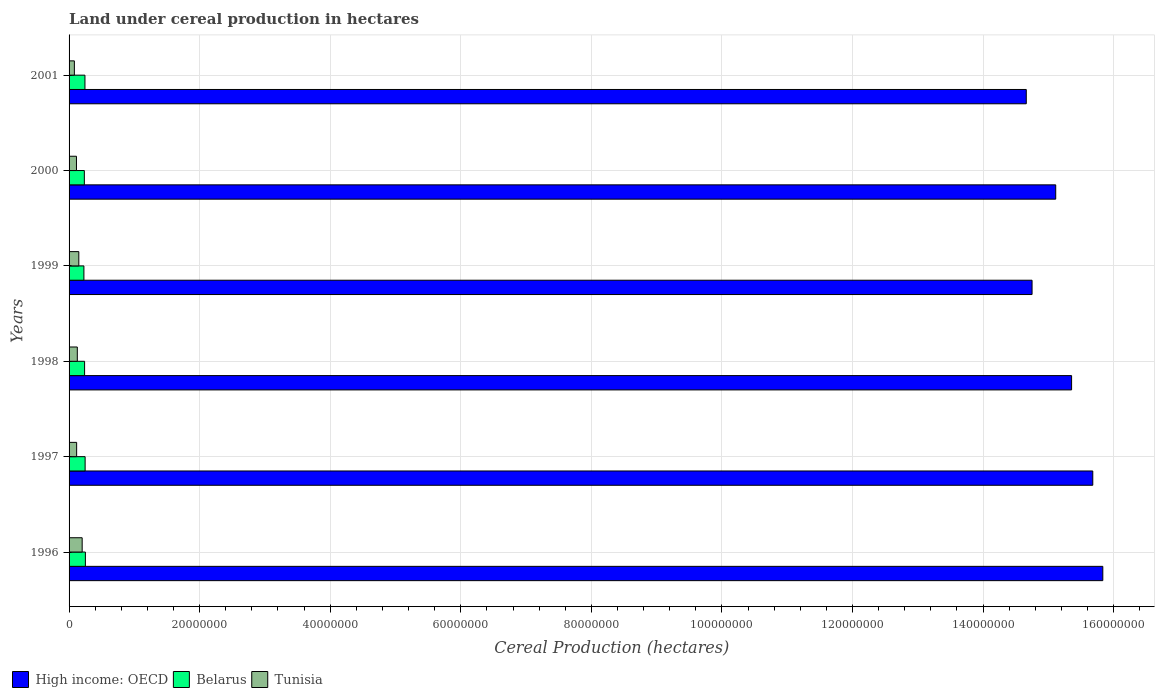How many groups of bars are there?
Make the answer very short. 6. Are the number of bars per tick equal to the number of legend labels?
Give a very brief answer. Yes. Are the number of bars on each tick of the Y-axis equal?
Your answer should be very brief. Yes. How many bars are there on the 2nd tick from the top?
Provide a succinct answer. 3. What is the label of the 1st group of bars from the top?
Ensure brevity in your answer.  2001. What is the land under cereal production in Tunisia in 1996?
Your answer should be compact. 2.01e+06. Across all years, what is the maximum land under cereal production in Belarus?
Ensure brevity in your answer.  2.50e+06. Across all years, what is the minimum land under cereal production in High income: OECD?
Make the answer very short. 1.47e+08. What is the total land under cereal production in High income: OECD in the graph?
Make the answer very short. 9.14e+08. What is the difference between the land under cereal production in Tunisia in 1997 and that in 2001?
Offer a very short reply. 3.46e+05. What is the difference between the land under cereal production in High income: OECD in 2000 and the land under cereal production in Belarus in 1998?
Offer a terse response. 1.49e+08. What is the average land under cereal production in High income: OECD per year?
Provide a short and direct response. 1.52e+08. In the year 1998, what is the difference between the land under cereal production in High income: OECD and land under cereal production in Belarus?
Your answer should be compact. 1.51e+08. In how many years, is the land under cereal production in Belarus greater than 88000000 hectares?
Give a very brief answer. 0. What is the ratio of the land under cereal production in Belarus in 2000 to that in 2001?
Provide a short and direct response. 0.96. What is the difference between the highest and the second highest land under cereal production in Tunisia?
Offer a very short reply. 5.13e+05. What is the difference between the highest and the lowest land under cereal production in Belarus?
Your response must be concise. 2.26e+05. In how many years, is the land under cereal production in Belarus greater than the average land under cereal production in Belarus taken over all years?
Make the answer very short. 3. Is the sum of the land under cereal production in Belarus in 1997 and 1998 greater than the maximum land under cereal production in High income: OECD across all years?
Your answer should be compact. No. What does the 3rd bar from the top in 2001 represents?
Your answer should be very brief. High income: OECD. What does the 1st bar from the bottom in 2001 represents?
Offer a terse response. High income: OECD. Is it the case that in every year, the sum of the land under cereal production in Tunisia and land under cereal production in High income: OECD is greater than the land under cereal production in Belarus?
Your answer should be compact. Yes. How many bars are there?
Provide a succinct answer. 18. Are the values on the major ticks of X-axis written in scientific E-notation?
Your answer should be compact. No. Does the graph contain grids?
Offer a terse response. Yes. How many legend labels are there?
Your answer should be very brief. 3. What is the title of the graph?
Provide a short and direct response. Land under cereal production in hectares. Does "Estonia" appear as one of the legend labels in the graph?
Your answer should be very brief. No. What is the label or title of the X-axis?
Give a very brief answer. Cereal Production (hectares). What is the label or title of the Y-axis?
Provide a succinct answer. Years. What is the Cereal Production (hectares) of High income: OECD in 1996?
Your answer should be very brief. 1.58e+08. What is the Cereal Production (hectares) of Belarus in 1996?
Provide a short and direct response. 2.50e+06. What is the Cereal Production (hectares) in Tunisia in 1996?
Give a very brief answer. 2.01e+06. What is the Cereal Production (hectares) in High income: OECD in 1997?
Your response must be concise. 1.57e+08. What is the Cereal Production (hectares) of Belarus in 1997?
Make the answer very short. 2.46e+06. What is the Cereal Production (hectares) in Tunisia in 1997?
Provide a short and direct response. 1.16e+06. What is the Cereal Production (hectares) in High income: OECD in 1998?
Your answer should be compact. 1.54e+08. What is the Cereal Production (hectares) in Belarus in 1998?
Your response must be concise. 2.38e+06. What is the Cereal Production (hectares) in Tunisia in 1998?
Your answer should be very brief. 1.26e+06. What is the Cereal Production (hectares) in High income: OECD in 1999?
Offer a terse response. 1.48e+08. What is the Cereal Production (hectares) in Belarus in 1999?
Offer a very short reply. 2.27e+06. What is the Cereal Production (hectares) in Tunisia in 1999?
Give a very brief answer. 1.49e+06. What is the Cereal Production (hectares) of High income: OECD in 2000?
Offer a very short reply. 1.51e+08. What is the Cereal Production (hectares) in Belarus in 2000?
Keep it short and to the point. 2.34e+06. What is the Cereal Production (hectares) in Tunisia in 2000?
Offer a terse response. 1.13e+06. What is the Cereal Production (hectares) of High income: OECD in 2001?
Make the answer very short. 1.47e+08. What is the Cereal Production (hectares) of Belarus in 2001?
Your answer should be very brief. 2.43e+06. What is the Cereal Production (hectares) of Tunisia in 2001?
Your answer should be compact. 8.13e+05. Across all years, what is the maximum Cereal Production (hectares) of High income: OECD?
Keep it short and to the point. 1.58e+08. Across all years, what is the maximum Cereal Production (hectares) of Belarus?
Ensure brevity in your answer.  2.50e+06. Across all years, what is the maximum Cereal Production (hectares) in Tunisia?
Provide a short and direct response. 2.01e+06. Across all years, what is the minimum Cereal Production (hectares) of High income: OECD?
Make the answer very short. 1.47e+08. Across all years, what is the minimum Cereal Production (hectares) in Belarus?
Keep it short and to the point. 2.27e+06. Across all years, what is the minimum Cereal Production (hectares) in Tunisia?
Provide a succinct answer. 8.13e+05. What is the total Cereal Production (hectares) of High income: OECD in the graph?
Your answer should be very brief. 9.14e+08. What is the total Cereal Production (hectares) in Belarus in the graph?
Your response must be concise. 1.44e+07. What is the total Cereal Production (hectares) of Tunisia in the graph?
Your response must be concise. 7.87e+06. What is the difference between the Cereal Production (hectares) in High income: OECD in 1996 and that in 1997?
Provide a short and direct response. 1.54e+06. What is the difference between the Cereal Production (hectares) in Belarus in 1996 and that in 1997?
Make the answer very short. 4.05e+04. What is the difference between the Cereal Production (hectares) of Tunisia in 1996 and that in 1997?
Your response must be concise. 8.46e+05. What is the difference between the Cereal Production (hectares) in High income: OECD in 1996 and that in 1998?
Keep it short and to the point. 4.78e+06. What is the difference between the Cereal Production (hectares) in Belarus in 1996 and that in 1998?
Make the answer very short. 1.22e+05. What is the difference between the Cereal Production (hectares) of Tunisia in 1996 and that in 1998?
Ensure brevity in your answer.  7.44e+05. What is the difference between the Cereal Production (hectares) in High income: OECD in 1996 and that in 1999?
Offer a terse response. 1.08e+07. What is the difference between the Cereal Production (hectares) of Belarus in 1996 and that in 1999?
Keep it short and to the point. 2.26e+05. What is the difference between the Cereal Production (hectares) in Tunisia in 1996 and that in 1999?
Keep it short and to the point. 5.13e+05. What is the difference between the Cereal Production (hectares) of High income: OECD in 1996 and that in 2000?
Ensure brevity in your answer.  7.21e+06. What is the difference between the Cereal Production (hectares) in Belarus in 1996 and that in 2000?
Give a very brief answer. 1.60e+05. What is the difference between the Cereal Production (hectares) in Tunisia in 1996 and that in 2000?
Ensure brevity in your answer.  8.72e+05. What is the difference between the Cereal Production (hectares) in High income: OECD in 1996 and that in 2001?
Your answer should be compact. 1.17e+07. What is the difference between the Cereal Production (hectares) of Belarus in 1996 and that in 2001?
Make the answer very short. 6.68e+04. What is the difference between the Cereal Production (hectares) in Tunisia in 1996 and that in 2001?
Make the answer very short. 1.19e+06. What is the difference between the Cereal Production (hectares) in High income: OECD in 1997 and that in 1998?
Ensure brevity in your answer.  3.25e+06. What is the difference between the Cereal Production (hectares) of Belarus in 1997 and that in 1998?
Make the answer very short. 8.12e+04. What is the difference between the Cereal Production (hectares) in Tunisia in 1997 and that in 1998?
Your answer should be very brief. -1.03e+05. What is the difference between the Cereal Production (hectares) in High income: OECD in 1997 and that in 1999?
Provide a short and direct response. 9.30e+06. What is the difference between the Cereal Production (hectares) in Belarus in 1997 and that in 1999?
Your response must be concise. 1.86e+05. What is the difference between the Cereal Production (hectares) in Tunisia in 1997 and that in 1999?
Make the answer very short. -3.33e+05. What is the difference between the Cereal Production (hectares) in High income: OECD in 1997 and that in 2000?
Provide a short and direct response. 5.68e+06. What is the difference between the Cereal Production (hectares) of Belarus in 1997 and that in 2000?
Offer a terse response. 1.20e+05. What is the difference between the Cereal Production (hectares) in Tunisia in 1997 and that in 2000?
Provide a succinct answer. 2.54e+04. What is the difference between the Cereal Production (hectares) of High income: OECD in 1997 and that in 2001?
Your answer should be compact. 1.02e+07. What is the difference between the Cereal Production (hectares) of Belarus in 1997 and that in 2001?
Your response must be concise. 2.63e+04. What is the difference between the Cereal Production (hectares) of Tunisia in 1997 and that in 2001?
Ensure brevity in your answer.  3.46e+05. What is the difference between the Cereal Production (hectares) of High income: OECD in 1998 and that in 1999?
Make the answer very short. 6.05e+06. What is the difference between the Cereal Production (hectares) of Belarus in 1998 and that in 1999?
Offer a terse response. 1.04e+05. What is the difference between the Cereal Production (hectares) of Tunisia in 1998 and that in 1999?
Your response must be concise. -2.30e+05. What is the difference between the Cereal Production (hectares) of High income: OECD in 1998 and that in 2000?
Your answer should be compact. 2.43e+06. What is the difference between the Cereal Production (hectares) of Belarus in 1998 and that in 2000?
Provide a short and direct response. 3.83e+04. What is the difference between the Cereal Production (hectares) of Tunisia in 1998 and that in 2000?
Make the answer very short. 1.28e+05. What is the difference between the Cereal Production (hectares) in High income: OECD in 1998 and that in 2001?
Offer a very short reply. 6.94e+06. What is the difference between the Cereal Production (hectares) in Belarus in 1998 and that in 2001?
Your answer should be very brief. -5.49e+04. What is the difference between the Cereal Production (hectares) of Tunisia in 1998 and that in 2001?
Your answer should be compact. 4.49e+05. What is the difference between the Cereal Production (hectares) of High income: OECD in 1999 and that in 2000?
Offer a terse response. -3.62e+06. What is the difference between the Cereal Production (hectares) in Belarus in 1999 and that in 2000?
Provide a succinct answer. -6.60e+04. What is the difference between the Cereal Production (hectares) of Tunisia in 1999 and that in 2000?
Your answer should be very brief. 3.58e+05. What is the difference between the Cereal Production (hectares) in High income: OECD in 1999 and that in 2001?
Make the answer very short. 8.86e+05. What is the difference between the Cereal Production (hectares) of Belarus in 1999 and that in 2001?
Provide a short and direct response. -1.59e+05. What is the difference between the Cereal Production (hectares) in Tunisia in 1999 and that in 2001?
Keep it short and to the point. 6.79e+05. What is the difference between the Cereal Production (hectares) in High income: OECD in 2000 and that in 2001?
Ensure brevity in your answer.  4.51e+06. What is the difference between the Cereal Production (hectares) in Belarus in 2000 and that in 2001?
Offer a very short reply. -9.32e+04. What is the difference between the Cereal Production (hectares) of Tunisia in 2000 and that in 2001?
Your answer should be compact. 3.21e+05. What is the difference between the Cereal Production (hectares) in High income: OECD in 1996 and the Cereal Production (hectares) in Belarus in 1997?
Your answer should be compact. 1.56e+08. What is the difference between the Cereal Production (hectares) in High income: OECD in 1996 and the Cereal Production (hectares) in Tunisia in 1997?
Provide a succinct answer. 1.57e+08. What is the difference between the Cereal Production (hectares) of Belarus in 1996 and the Cereal Production (hectares) of Tunisia in 1997?
Your answer should be very brief. 1.34e+06. What is the difference between the Cereal Production (hectares) in High income: OECD in 1996 and the Cereal Production (hectares) in Belarus in 1998?
Your answer should be very brief. 1.56e+08. What is the difference between the Cereal Production (hectares) in High income: OECD in 1996 and the Cereal Production (hectares) in Tunisia in 1998?
Your answer should be compact. 1.57e+08. What is the difference between the Cereal Production (hectares) in Belarus in 1996 and the Cereal Production (hectares) in Tunisia in 1998?
Your response must be concise. 1.24e+06. What is the difference between the Cereal Production (hectares) of High income: OECD in 1996 and the Cereal Production (hectares) of Belarus in 1999?
Your answer should be compact. 1.56e+08. What is the difference between the Cereal Production (hectares) in High income: OECD in 1996 and the Cereal Production (hectares) in Tunisia in 1999?
Offer a terse response. 1.57e+08. What is the difference between the Cereal Production (hectares) of Belarus in 1996 and the Cereal Production (hectares) of Tunisia in 1999?
Ensure brevity in your answer.  1.01e+06. What is the difference between the Cereal Production (hectares) in High income: OECD in 1996 and the Cereal Production (hectares) in Belarus in 2000?
Your response must be concise. 1.56e+08. What is the difference between the Cereal Production (hectares) of High income: OECD in 1996 and the Cereal Production (hectares) of Tunisia in 2000?
Provide a short and direct response. 1.57e+08. What is the difference between the Cereal Production (hectares) in Belarus in 1996 and the Cereal Production (hectares) in Tunisia in 2000?
Make the answer very short. 1.36e+06. What is the difference between the Cereal Production (hectares) of High income: OECD in 1996 and the Cereal Production (hectares) of Belarus in 2001?
Offer a terse response. 1.56e+08. What is the difference between the Cereal Production (hectares) in High income: OECD in 1996 and the Cereal Production (hectares) in Tunisia in 2001?
Keep it short and to the point. 1.58e+08. What is the difference between the Cereal Production (hectares) of Belarus in 1996 and the Cereal Production (hectares) of Tunisia in 2001?
Offer a terse response. 1.69e+06. What is the difference between the Cereal Production (hectares) in High income: OECD in 1997 and the Cereal Production (hectares) in Belarus in 1998?
Your response must be concise. 1.54e+08. What is the difference between the Cereal Production (hectares) of High income: OECD in 1997 and the Cereal Production (hectares) of Tunisia in 1998?
Ensure brevity in your answer.  1.56e+08. What is the difference between the Cereal Production (hectares) in Belarus in 1997 and the Cereal Production (hectares) in Tunisia in 1998?
Provide a short and direct response. 1.20e+06. What is the difference between the Cereal Production (hectares) of High income: OECD in 1997 and the Cereal Production (hectares) of Belarus in 1999?
Ensure brevity in your answer.  1.55e+08. What is the difference between the Cereal Production (hectares) of High income: OECD in 1997 and the Cereal Production (hectares) of Tunisia in 1999?
Your answer should be compact. 1.55e+08. What is the difference between the Cereal Production (hectares) of Belarus in 1997 and the Cereal Production (hectares) of Tunisia in 1999?
Provide a succinct answer. 9.66e+05. What is the difference between the Cereal Production (hectares) of High income: OECD in 1997 and the Cereal Production (hectares) of Belarus in 2000?
Make the answer very short. 1.54e+08. What is the difference between the Cereal Production (hectares) in High income: OECD in 1997 and the Cereal Production (hectares) in Tunisia in 2000?
Provide a short and direct response. 1.56e+08. What is the difference between the Cereal Production (hectares) in Belarus in 1997 and the Cereal Production (hectares) in Tunisia in 2000?
Offer a terse response. 1.32e+06. What is the difference between the Cereal Production (hectares) of High income: OECD in 1997 and the Cereal Production (hectares) of Belarus in 2001?
Ensure brevity in your answer.  1.54e+08. What is the difference between the Cereal Production (hectares) in High income: OECD in 1997 and the Cereal Production (hectares) in Tunisia in 2001?
Keep it short and to the point. 1.56e+08. What is the difference between the Cereal Production (hectares) of Belarus in 1997 and the Cereal Production (hectares) of Tunisia in 2001?
Give a very brief answer. 1.65e+06. What is the difference between the Cereal Production (hectares) in High income: OECD in 1998 and the Cereal Production (hectares) in Belarus in 1999?
Your answer should be very brief. 1.51e+08. What is the difference between the Cereal Production (hectares) in High income: OECD in 1998 and the Cereal Production (hectares) in Tunisia in 1999?
Your answer should be compact. 1.52e+08. What is the difference between the Cereal Production (hectares) of Belarus in 1998 and the Cereal Production (hectares) of Tunisia in 1999?
Your answer should be very brief. 8.85e+05. What is the difference between the Cereal Production (hectares) of High income: OECD in 1998 and the Cereal Production (hectares) of Belarus in 2000?
Offer a very short reply. 1.51e+08. What is the difference between the Cereal Production (hectares) in High income: OECD in 1998 and the Cereal Production (hectares) in Tunisia in 2000?
Offer a very short reply. 1.52e+08. What is the difference between the Cereal Production (hectares) in Belarus in 1998 and the Cereal Production (hectares) in Tunisia in 2000?
Ensure brevity in your answer.  1.24e+06. What is the difference between the Cereal Production (hectares) of High income: OECD in 1998 and the Cereal Production (hectares) of Belarus in 2001?
Provide a succinct answer. 1.51e+08. What is the difference between the Cereal Production (hectares) of High income: OECD in 1998 and the Cereal Production (hectares) of Tunisia in 2001?
Provide a short and direct response. 1.53e+08. What is the difference between the Cereal Production (hectares) in Belarus in 1998 and the Cereal Production (hectares) in Tunisia in 2001?
Your answer should be very brief. 1.56e+06. What is the difference between the Cereal Production (hectares) in High income: OECD in 1999 and the Cereal Production (hectares) in Belarus in 2000?
Your response must be concise. 1.45e+08. What is the difference between the Cereal Production (hectares) of High income: OECD in 1999 and the Cereal Production (hectares) of Tunisia in 2000?
Give a very brief answer. 1.46e+08. What is the difference between the Cereal Production (hectares) of Belarus in 1999 and the Cereal Production (hectares) of Tunisia in 2000?
Your answer should be very brief. 1.14e+06. What is the difference between the Cereal Production (hectares) in High income: OECD in 1999 and the Cereal Production (hectares) in Belarus in 2001?
Provide a succinct answer. 1.45e+08. What is the difference between the Cereal Production (hectares) in High income: OECD in 1999 and the Cereal Production (hectares) in Tunisia in 2001?
Your answer should be very brief. 1.47e+08. What is the difference between the Cereal Production (hectares) in Belarus in 1999 and the Cereal Production (hectares) in Tunisia in 2001?
Provide a succinct answer. 1.46e+06. What is the difference between the Cereal Production (hectares) of High income: OECD in 2000 and the Cereal Production (hectares) of Belarus in 2001?
Your answer should be compact. 1.49e+08. What is the difference between the Cereal Production (hectares) of High income: OECD in 2000 and the Cereal Production (hectares) of Tunisia in 2001?
Your answer should be very brief. 1.50e+08. What is the difference between the Cereal Production (hectares) of Belarus in 2000 and the Cereal Production (hectares) of Tunisia in 2001?
Provide a succinct answer. 1.53e+06. What is the average Cereal Production (hectares) of High income: OECD per year?
Your answer should be very brief. 1.52e+08. What is the average Cereal Production (hectares) of Belarus per year?
Make the answer very short. 2.40e+06. What is the average Cereal Production (hectares) in Tunisia per year?
Provide a succinct answer. 1.31e+06. In the year 1996, what is the difference between the Cereal Production (hectares) of High income: OECD and Cereal Production (hectares) of Belarus?
Make the answer very short. 1.56e+08. In the year 1996, what is the difference between the Cereal Production (hectares) of High income: OECD and Cereal Production (hectares) of Tunisia?
Make the answer very short. 1.56e+08. In the year 1996, what is the difference between the Cereal Production (hectares) of Belarus and Cereal Production (hectares) of Tunisia?
Give a very brief answer. 4.93e+05. In the year 1997, what is the difference between the Cereal Production (hectares) of High income: OECD and Cereal Production (hectares) of Belarus?
Make the answer very short. 1.54e+08. In the year 1997, what is the difference between the Cereal Production (hectares) in High income: OECD and Cereal Production (hectares) in Tunisia?
Provide a succinct answer. 1.56e+08. In the year 1997, what is the difference between the Cereal Production (hectares) in Belarus and Cereal Production (hectares) in Tunisia?
Offer a terse response. 1.30e+06. In the year 1998, what is the difference between the Cereal Production (hectares) of High income: OECD and Cereal Production (hectares) of Belarus?
Your answer should be compact. 1.51e+08. In the year 1998, what is the difference between the Cereal Production (hectares) in High income: OECD and Cereal Production (hectares) in Tunisia?
Offer a very short reply. 1.52e+08. In the year 1998, what is the difference between the Cereal Production (hectares) of Belarus and Cereal Production (hectares) of Tunisia?
Keep it short and to the point. 1.12e+06. In the year 1999, what is the difference between the Cereal Production (hectares) in High income: OECD and Cereal Production (hectares) in Belarus?
Your answer should be compact. 1.45e+08. In the year 1999, what is the difference between the Cereal Production (hectares) of High income: OECD and Cereal Production (hectares) of Tunisia?
Your answer should be compact. 1.46e+08. In the year 1999, what is the difference between the Cereal Production (hectares) of Belarus and Cereal Production (hectares) of Tunisia?
Your answer should be very brief. 7.81e+05. In the year 2000, what is the difference between the Cereal Production (hectares) of High income: OECD and Cereal Production (hectares) of Belarus?
Give a very brief answer. 1.49e+08. In the year 2000, what is the difference between the Cereal Production (hectares) in High income: OECD and Cereal Production (hectares) in Tunisia?
Your response must be concise. 1.50e+08. In the year 2000, what is the difference between the Cereal Production (hectares) in Belarus and Cereal Production (hectares) in Tunisia?
Keep it short and to the point. 1.20e+06. In the year 2001, what is the difference between the Cereal Production (hectares) of High income: OECD and Cereal Production (hectares) of Belarus?
Offer a very short reply. 1.44e+08. In the year 2001, what is the difference between the Cereal Production (hectares) in High income: OECD and Cereal Production (hectares) in Tunisia?
Provide a short and direct response. 1.46e+08. In the year 2001, what is the difference between the Cereal Production (hectares) of Belarus and Cereal Production (hectares) of Tunisia?
Offer a terse response. 1.62e+06. What is the ratio of the Cereal Production (hectares) in High income: OECD in 1996 to that in 1997?
Make the answer very short. 1.01. What is the ratio of the Cereal Production (hectares) in Belarus in 1996 to that in 1997?
Your response must be concise. 1.02. What is the ratio of the Cereal Production (hectares) in Tunisia in 1996 to that in 1997?
Ensure brevity in your answer.  1.73. What is the ratio of the Cereal Production (hectares) in High income: OECD in 1996 to that in 1998?
Provide a succinct answer. 1.03. What is the ratio of the Cereal Production (hectares) in Belarus in 1996 to that in 1998?
Your answer should be very brief. 1.05. What is the ratio of the Cereal Production (hectares) in Tunisia in 1996 to that in 1998?
Your answer should be compact. 1.59. What is the ratio of the Cereal Production (hectares) of High income: OECD in 1996 to that in 1999?
Offer a very short reply. 1.07. What is the ratio of the Cereal Production (hectares) of Belarus in 1996 to that in 1999?
Provide a short and direct response. 1.1. What is the ratio of the Cereal Production (hectares) in Tunisia in 1996 to that in 1999?
Keep it short and to the point. 1.34. What is the ratio of the Cereal Production (hectares) of High income: OECD in 1996 to that in 2000?
Your answer should be compact. 1.05. What is the ratio of the Cereal Production (hectares) in Belarus in 1996 to that in 2000?
Provide a short and direct response. 1.07. What is the ratio of the Cereal Production (hectares) in Tunisia in 1996 to that in 2000?
Provide a short and direct response. 1.77. What is the ratio of the Cereal Production (hectares) of High income: OECD in 1996 to that in 2001?
Provide a short and direct response. 1.08. What is the ratio of the Cereal Production (hectares) in Belarus in 1996 to that in 2001?
Make the answer very short. 1.03. What is the ratio of the Cereal Production (hectares) in Tunisia in 1996 to that in 2001?
Provide a short and direct response. 2.47. What is the ratio of the Cereal Production (hectares) in High income: OECD in 1997 to that in 1998?
Provide a succinct answer. 1.02. What is the ratio of the Cereal Production (hectares) of Belarus in 1997 to that in 1998?
Give a very brief answer. 1.03. What is the ratio of the Cereal Production (hectares) in Tunisia in 1997 to that in 1998?
Offer a very short reply. 0.92. What is the ratio of the Cereal Production (hectares) in High income: OECD in 1997 to that in 1999?
Ensure brevity in your answer.  1.06. What is the ratio of the Cereal Production (hectares) in Belarus in 1997 to that in 1999?
Your answer should be very brief. 1.08. What is the ratio of the Cereal Production (hectares) in Tunisia in 1997 to that in 1999?
Offer a very short reply. 0.78. What is the ratio of the Cereal Production (hectares) of High income: OECD in 1997 to that in 2000?
Your response must be concise. 1.04. What is the ratio of the Cereal Production (hectares) in Belarus in 1997 to that in 2000?
Your answer should be very brief. 1.05. What is the ratio of the Cereal Production (hectares) in Tunisia in 1997 to that in 2000?
Ensure brevity in your answer.  1.02. What is the ratio of the Cereal Production (hectares) of High income: OECD in 1997 to that in 2001?
Give a very brief answer. 1.07. What is the ratio of the Cereal Production (hectares) of Belarus in 1997 to that in 2001?
Your response must be concise. 1.01. What is the ratio of the Cereal Production (hectares) in Tunisia in 1997 to that in 2001?
Your answer should be compact. 1.43. What is the ratio of the Cereal Production (hectares) of High income: OECD in 1998 to that in 1999?
Provide a succinct answer. 1.04. What is the ratio of the Cereal Production (hectares) of Belarus in 1998 to that in 1999?
Your answer should be compact. 1.05. What is the ratio of the Cereal Production (hectares) in Tunisia in 1998 to that in 1999?
Keep it short and to the point. 0.85. What is the ratio of the Cereal Production (hectares) of High income: OECD in 1998 to that in 2000?
Make the answer very short. 1.02. What is the ratio of the Cereal Production (hectares) of Belarus in 1998 to that in 2000?
Offer a terse response. 1.02. What is the ratio of the Cereal Production (hectares) in Tunisia in 1998 to that in 2000?
Offer a terse response. 1.11. What is the ratio of the Cereal Production (hectares) of High income: OECD in 1998 to that in 2001?
Your answer should be very brief. 1.05. What is the ratio of the Cereal Production (hectares) in Belarus in 1998 to that in 2001?
Your response must be concise. 0.98. What is the ratio of the Cereal Production (hectares) in Tunisia in 1998 to that in 2001?
Your answer should be compact. 1.55. What is the ratio of the Cereal Production (hectares) in High income: OECD in 1999 to that in 2000?
Make the answer very short. 0.98. What is the ratio of the Cereal Production (hectares) of Belarus in 1999 to that in 2000?
Keep it short and to the point. 0.97. What is the ratio of the Cereal Production (hectares) in Tunisia in 1999 to that in 2000?
Your answer should be very brief. 1.32. What is the ratio of the Cereal Production (hectares) of Belarus in 1999 to that in 2001?
Provide a short and direct response. 0.93. What is the ratio of the Cereal Production (hectares) in Tunisia in 1999 to that in 2001?
Give a very brief answer. 1.84. What is the ratio of the Cereal Production (hectares) in High income: OECD in 2000 to that in 2001?
Offer a terse response. 1.03. What is the ratio of the Cereal Production (hectares) of Belarus in 2000 to that in 2001?
Provide a succinct answer. 0.96. What is the ratio of the Cereal Production (hectares) of Tunisia in 2000 to that in 2001?
Your response must be concise. 1.4. What is the difference between the highest and the second highest Cereal Production (hectares) of High income: OECD?
Provide a succinct answer. 1.54e+06. What is the difference between the highest and the second highest Cereal Production (hectares) of Belarus?
Make the answer very short. 4.05e+04. What is the difference between the highest and the second highest Cereal Production (hectares) of Tunisia?
Ensure brevity in your answer.  5.13e+05. What is the difference between the highest and the lowest Cereal Production (hectares) in High income: OECD?
Provide a short and direct response. 1.17e+07. What is the difference between the highest and the lowest Cereal Production (hectares) of Belarus?
Keep it short and to the point. 2.26e+05. What is the difference between the highest and the lowest Cereal Production (hectares) of Tunisia?
Make the answer very short. 1.19e+06. 